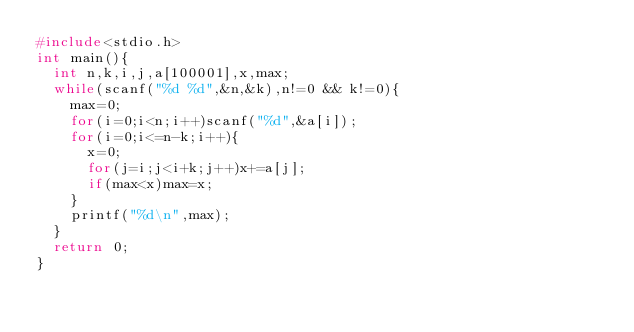<code> <loc_0><loc_0><loc_500><loc_500><_C_>#include<stdio.h>
int main(){
	int n,k,i,j,a[100001],x,max;
	while(scanf("%d %d",&n,&k),n!=0 && k!=0){
		max=0;
		for(i=0;i<n;i++)scanf("%d",&a[i]);
		for(i=0;i<=n-k;i++){
			x=0;
			for(j=i;j<i+k;j++)x+=a[j];
			if(max<x)max=x;
		}
		printf("%d\n",max);
	}
	return 0;
}
</code> 